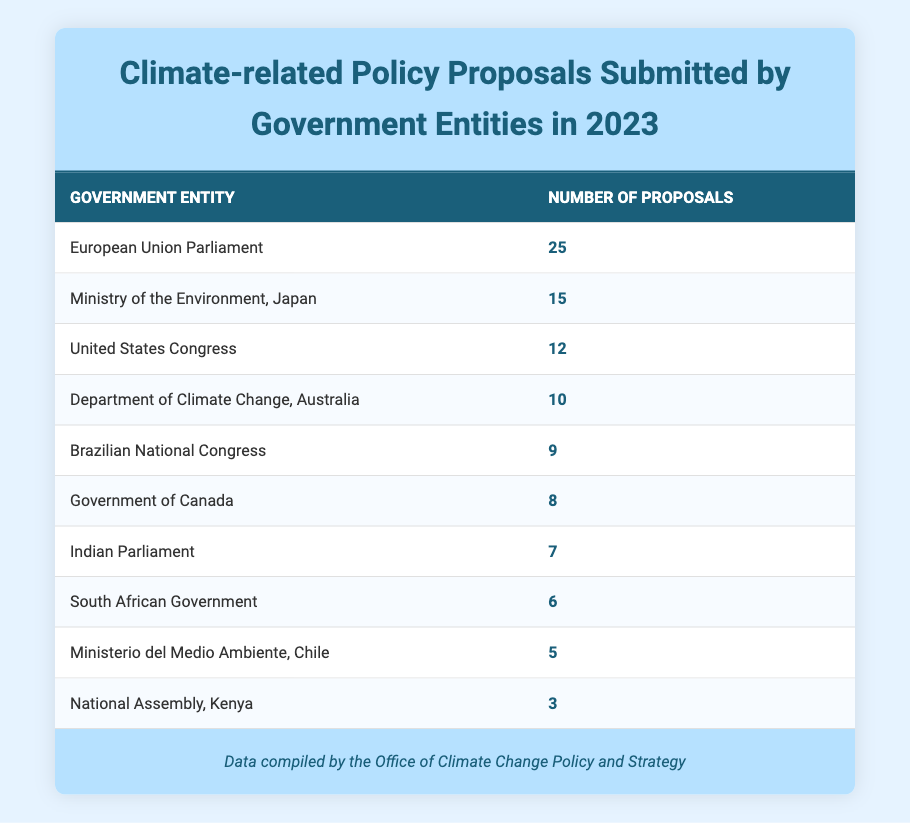What is the highest number of proposals submitted by a single entity? The table indicates that the European Union Parliament submitted the highest number of proposals, which is 25.
Answer: 25 Which government entity submitted the fewest proposals? According to the table, the National Assembly of Kenya submitted the fewest proposals, totaling 3.
Answer: 3 What is the total number of proposals submitted by all entities? To find the total, add up the number of proposals from each entity: 12 + 25 + 8 + 15 + 5 + 10 + 3 + 7 + 6 + 9 = 100.
Answer: 100 Is the government of Canada among the top three entities with the most proposals? Based on the table, the government of Canada is not in the top three, as it submitted 8 proposals, which is lower than those of the EU Parliament, Japan, and the US Congress.
Answer: No What is the average number of proposals submitted by the listed entities? There are 10 entities in total. To find the average, sum the number of proposals (100) and divide by the number of entities (10). Thus, the average is 100 / 10 = 10.
Answer: 10 How many more proposals did the European Union Parliament submit compared to the Brazilian National Congress? The European Union Parliament submitted 25 proposals, while the Brazilian National Congress submitted 9. To find the difference, subtract 9 from 25: 25 - 9 = 16.
Answer: 16 Was the total number of proposals submitted by South Africa and Canada greater than the number submitted by Japan? The South African Government submitted 6 proposals, and the Government of Canada submitted 8. Together, they submitted 6 + 8 = 14. The Ministry of the Environment, Japan submitted 15 proposals. Since 14 is less than 15, the combined number is not greater.
Answer: No What percentage of the total proposals were submitted by the United States Congress? The United States Congress submitted 12 proposals out of the total 100. To find the percentage, divide 12 by 100 and then multiply by 100: (12 / 100) * 100 = 12%.
Answer: 12% 